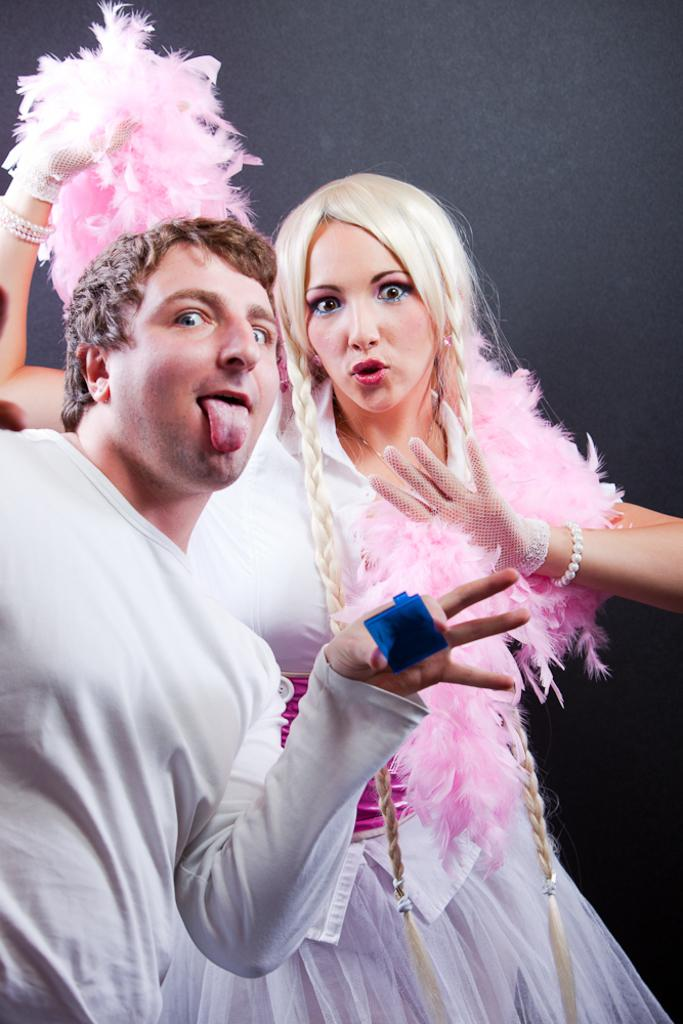What is the main subject of the image? There is a person in the image. Can you describe the person in the image? There is a woman in the image. What is the woman holding in the image? The woman is holding a blue color object. What type of bead is the woman wearing in the image? There is no bead visible on the woman in the image. How does the blue color object affect the woman's mood in the image? The provided facts do not mention the woman's mood or any effect the blue color object might have on it. 